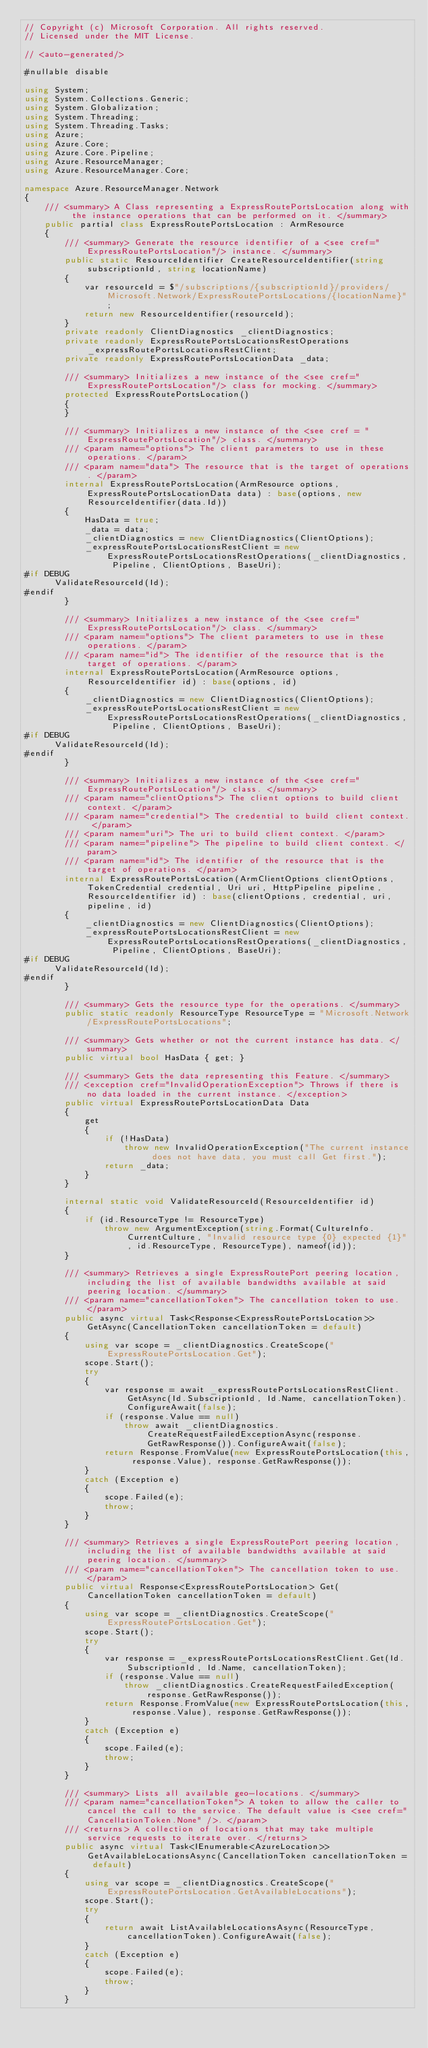Convert code to text. <code><loc_0><loc_0><loc_500><loc_500><_C#_>// Copyright (c) Microsoft Corporation. All rights reserved.
// Licensed under the MIT License.

// <auto-generated/>

#nullable disable

using System;
using System.Collections.Generic;
using System.Globalization;
using System.Threading;
using System.Threading.Tasks;
using Azure;
using Azure.Core;
using Azure.Core.Pipeline;
using Azure.ResourceManager;
using Azure.ResourceManager.Core;

namespace Azure.ResourceManager.Network
{
    /// <summary> A Class representing a ExpressRoutePortsLocation along with the instance operations that can be performed on it. </summary>
    public partial class ExpressRoutePortsLocation : ArmResource
    {
        /// <summary> Generate the resource identifier of a <see cref="ExpressRoutePortsLocation"/> instance. </summary>
        public static ResourceIdentifier CreateResourceIdentifier(string subscriptionId, string locationName)
        {
            var resourceId = $"/subscriptions/{subscriptionId}/providers/Microsoft.Network/ExpressRoutePortsLocations/{locationName}";
            return new ResourceIdentifier(resourceId);
        }
        private readonly ClientDiagnostics _clientDiagnostics;
        private readonly ExpressRoutePortsLocationsRestOperations _expressRoutePortsLocationsRestClient;
        private readonly ExpressRoutePortsLocationData _data;

        /// <summary> Initializes a new instance of the <see cref="ExpressRoutePortsLocation"/> class for mocking. </summary>
        protected ExpressRoutePortsLocation()
        {
        }

        /// <summary> Initializes a new instance of the <see cref = "ExpressRoutePortsLocation"/> class. </summary>
        /// <param name="options"> The client parameters to use in these operations. </param>
        /// <param name="data"> The resource that is the target of operations. </param>
        internal ExpressRoutePortsLocation(ArmResource options, ExpressRoutePortsLocationData data) : base(options, new ResourceIdentifier(data.Id))
        {
            HasData = true;
            _data = data;
            _clientDiagnostics = new ClientDiagnostics(ClientOptions);
            _expressRoutePortsLocationsRestClient = new ExpressRoutePortsLocationsRestOperations(_clientDiagnostics, Pipeline, ClientOptions, BaseUri);
#if DEBUG
			ValidateResourceId(Id);
#endif
        }

        /// <summary> Initializes a new instance of the <see cref="ExpressRoutePortsLocation"/> class. </summary>
        /// <param name="options"> The client parameters to use in these operations. </param>
        /// <param name="id"> The identifier of the resource that is the target of operations. </param>
        internal ExpressRoutePortsLocation(ArmResource options, ResourceIdentifier id) : base(options, id)
        {
            _clientDiagnostics = new ClientDiagnostics(ClientOptions);
            _expressRoutePortsLocationsRestClient = new ExpressRoutePortsLocationsRestOperations(_clientDiagnostics, Pipeline, ClientOptions, BaseUri);
#if DEBUG
			ValidateResourceId(Id);
#endif
        }

        /// <summary> Initializes a new instance of the <see cref="ExpressRoutePortsLocation"/> class. </summary>
        /// <param name="clientOptions"> The client options to build client context. </param>
        /// <param name="credential"> The credential to build client context. </param>
        /// <param name="uri"> The uri to build client context. </param>
        /// <param name="pipeline"> The pipeline to build client context. </param>
        /// <param name="id"> The identifier of the resource that is the target of operations. </param>
        internal ExpressRoutePortsLocation(ArmClientOptions clientOptions, TokenCredential credential, Uri uri, HttpPipeline pipeline, ResourceIdentifier id) : base(clientOptions, credential, uri, pipeline, id)
        {
            _clientDiagnostics = new ClientDiagnostics(ClientOptions);
            _expressRoutePortsLocationsRestClient = new ExpressRoutePortsLocationsRestOperations(_clientDiagnostics, Pipeline, ClientOptions, BaseUri);
#if DEBUG
			ValidateResourceId(Id);
#endif
        }

        /// <summary> Gets the resource type for the operations. </summary>
        public static readonly ResourceType ResourceType = "Microsoft.Network/ExpressRoutePortsLocations";

        /// <summary> Gets whether or not the current instance has data. </summary>
        public virtual bool HasData { get; }

        /// <summary> Gets the data representing this Feature. </summary>
        /// <exception cref="InvalidOperationException"> Throws if there is no data loaded in the current instance. </exception>
        public virtual ExpressRoutePortsLocationData Data
        {
            get
            {
                if (!HasData)
                    throw new InvalidOperationException("The current instance does not have data, you must call Get first.");
                return _data;
            }
        }

        internal static void ValidateResourceId(ResourceIdentifier id)
        {
            if (id.ResourceType != ResourceType)
                throw new ArgumentException(string.Format(CultureInfo.CurrentCulture, "Invalid resource type {0} expected {1}", id.ResourceType, ResourceType), nameof(id));
        }

        /// <summary> Retrieves a single ExpressRoutePort peering location, including the list of available bandwidths available at said peering location. </summary>
        /// <param name="cancellationToken"> The cancellation token to use. </param>
        public async virtual Task<Response<ExpressRoutePortsLocation>> GetAsync(CancellationToken cancellationToken = default)
        {
            using var scope = _clientDiagnostics.CreateScope("ExpressRoutePortsLocation.Get");
            scope.Start();
            try
            {
                var response = await _expressRoutePortsLocationsRestClient.GetAsync(Id.SubscriptionId, Id.Name, cancellationToken).ConfigureAwait(false);
                if (response.Value == null)
                    throw await _clientDiagnostics.CreateRequestFailedExceptionAsync(response.GetRawResponse()).ConfigureAwait(false);
                return Response.FromValue(new ExpressRoutePortsLocation(this, response.Value), response.GetRawResponse());
            }
            catch (Exception e)
            {
                scope.Failed(e);
                throw;
            }
        }

        /// <summary> Retrieves a single ExpressRoutePort peering location, including the list of available bandwidths available at said peering location. </summary>
        /// <param name="cancellationToken"> The cancellation token to use. </param>
        public virtual Response<ExpressRoutePortsLocation> Get(CancellationToken cancellationToken = default)
        {
            using var scope = _clientDiagnostics.CreateScope("ExpressRoutePortsLocation.Get");
            scope.Start();
            try
            {
                var response = _expressRoutePortsLocationsRestClient.Get(Id.SubscriptionId, Id.Name, cancellationToken);
                if (response.Value == null)
                    throw _clientDiagnostics.CreateRequestFailedException(response.GetRawResponse());
                return Response.FromValue(new ExpressRoutePortsLocation(this, response.Value), response.GetRawResponse());
            }
            catch (Exception e)
            {
                scope.Failed(e);
                throw;
            }
        }

        /// <summary> Lists all available geo-locations. </summary>
        /// <param name="cancellationToken"> A token to allow the caller to cancel the call to the service. The default value is <see cref="CancellationToken.None" />. </param>
        /// <returns> A collection of locations that may take multiple service requests to iterate over. </returns>
        public async virtual Task<IEnumerable<AzureLocation>> GetAvailableLocationsAsync(CancellationToken cancellationToken = default)
        {
            using var scope = _clientDiagnostics.CreateScope("ExpressRoutePortsLocation.GetAvailableLocations");
            scope.Start();
            try
            {
                return await ListAvailableLocationsAsync(ResourceType, cancellationToken).ConfigureAwait(false);
            }
            catch (Exception e)
            {
                scope.Failed(e);
                throw;
            }
        }
</code> 